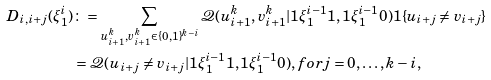<formula> <loc_0><loc_0><loc_500><loc_500>D _ { i , i + j } ( \xi _ { 1 } ^ { i } ) & \colon = \sum _ { u _ { i + 1 } ^ { k } , v _ { i + 1 } ^ { k } \in \{ 0 , 1 \} ^ { k - i } } \mathcal { Q } ( u _ { i + 1 } ^ { k } , v _ { i + 1 } ^ { k } | 1 \xi _ { 1 } ^ { i - 1 } 1 , 1 \xi _ { 1 } ^ { i - 1 } 0 ) { 1 } \{ u _ { i + j } \neq v _ { i + j } \} \\ & = \mathcal { Q } ( u _ { i + j } \neq v _ { i + j } | 1 \xi _ { 1 } ^ { i - 1 } 1 , 1 \xi _ { 1 } ^ { i - 1 } 0 ) , f o r j = 0 , \dots , k - i ,</formula> 